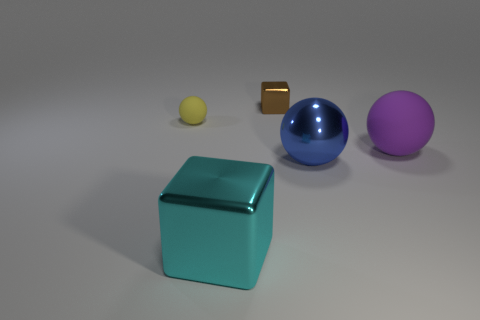What number of large yellow cylinders are there?
Provide a short and direct response. 0. What number of metallic objects are large green cylinders or yellow spheres?
Give a very brief answer. 0. The tiny object that is behind the matte ball that is left of the small metal cube is made of what material?
Keep it short and to the point. Metal. What size is the cyan metallic block?
Offer a very short reply. Large. How many purple things are the same size as the brown cube?
Keep it short and to the point. 0. How many yellow matte objects have the same shape as the big cyan object?
Give a very brief answer. 0. Are there the same number of cyan blocks behind the blue ball and tiny gray cubes?
Make the answer very short. Yes. Are there any other things that have the same size as the blue metal object?
Ensure brevity in your answer.  Yes. There is another metallic object that is the same size as the blue shiny object; what shape is it?
Provide a short and direct response. Cube. Are there any other big purple objects that have the same shape as the purple matte thing?
Your response must be concise. No. 